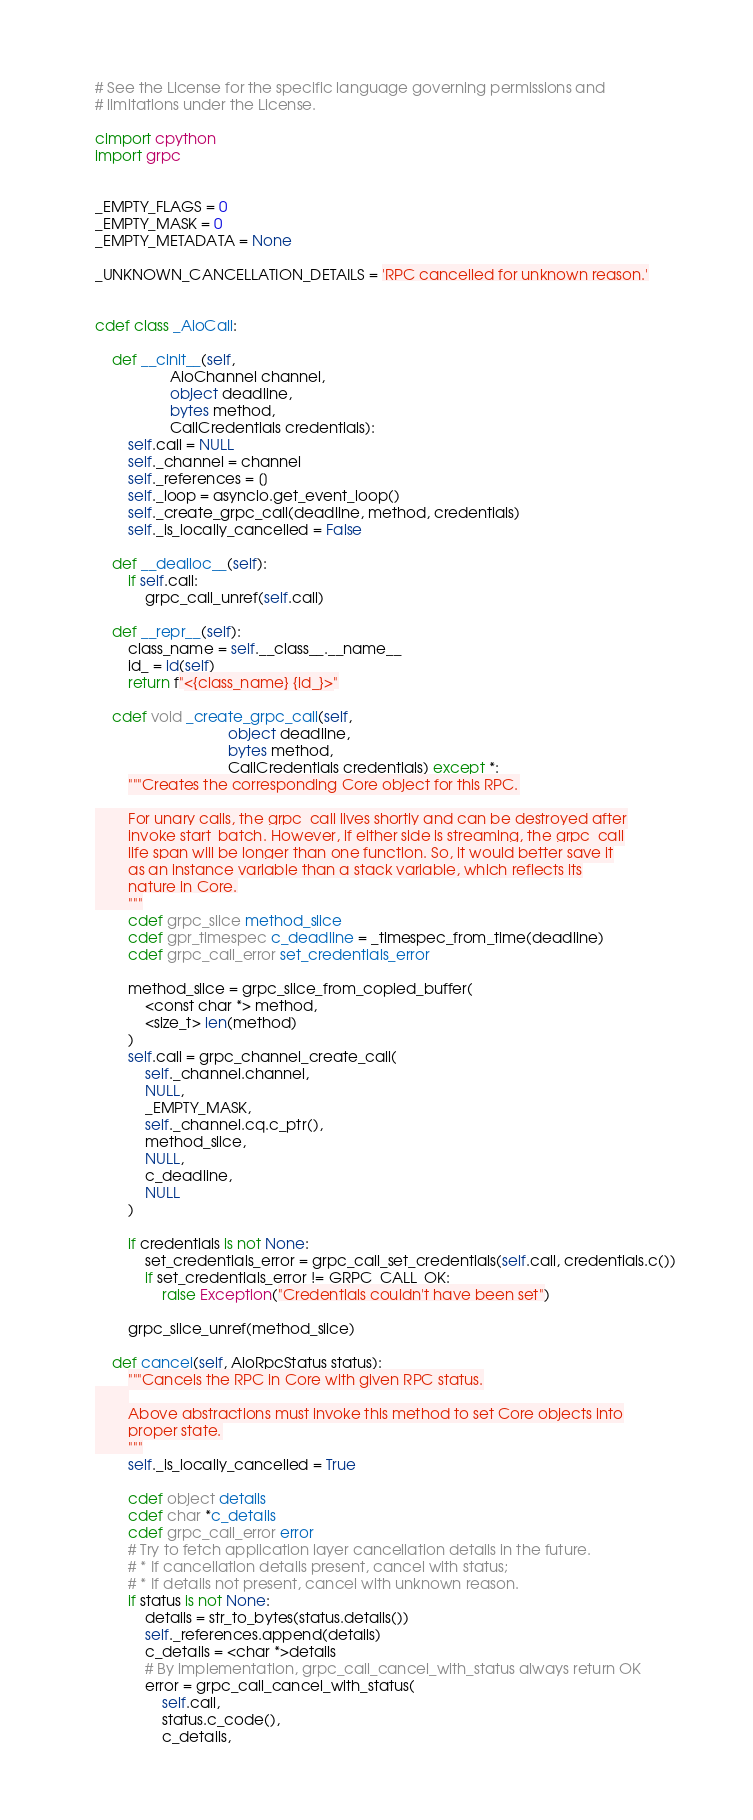<code> <loc_0><loc_0><loc_500><loc_500><_Cython_># See the License for the specific language governing permissions and
# limitations under the License.

cimport cpython
import grpc


_EMPTY_FLAGS = 0
_EMPTY_MASK = 0
_EMPTY_METADATA = None

_UNKNOWN_CANCELLATION_DETAILS = 'RPC cancelled for unknown reason.'


cdef class _AioCall:

    def __cinit__(self,
                  AioChannel channel,
                  object deadline,
                  bytes method,
                  CallCredentials credentials):
        self.call = NULL
        self._channel = channel
        self._references = []
        self._loop = asyncio.get_event_loop()
        self._create_grpc_call(deadline, method, credentials)
        self._is_locally_cancelled = False

    def __dealloc__(self):
        if self.call:
            grpc_call_unref(self.call)

    def __repr__(self):
        class_name = self.__class__.__name__
        id_ = id(self)
        return f"<{class_name} {id_}>"

    cdef void _create_grpc_call(self,
                                object deadline,
                                bytes method,
                                CallCredentials credentials) except *:
        """Creates the corresponding Core object for this RPC.

        For unary calls, the grpc_call lives shortly and can be destroyed after
        invoke start_batch. However, if either side is streaming, the grpc_call
        life span will be longer than one function. So, it would better save it
        as an instance variable than a stack variable, which reflects its
        nature in Core.
        """
        cdef grpc_slice method_slice
        cdef gpr_timespec c_deadline = _timespec_from_time(deadline)
        cdef grpc_call_error set_credentials_error

        method_slice = grpc_slice_from_copied_buffer(
            <const char *> method,
            <size_t> len(method)
        )
        self.call = grpc_channel_create_call(
            self._channel.channel,
            NULL,
            _EMPTY_MASK,
            self._channel.cq.c_ptr(),
            method_slice,
            NULL,
            c_deadline,
            NULL
        )

        if credentials is not None:
            set_credentials_error = grpc_call_set_credentials(self.call, credentials.c())
            if set_credentials_error != GRPC_CALL_OK:
                raise Exception("Credentials couldn't have been set")

        grpc_slice_unref(method_slice)

    def cancel(self, AioRpcStatus status):
        """Cancels the RPC in Core with given RPC status.
        
        Above abstractions must invoke this method to set Core objects into
        proper state.
        """
        self._is_locally_cancelled = True

        cdef object details
        cdef char *c_details
        cdef grpc_call_error error
        # Try to fetch application layer cancellation details in the future.
        # * If cancellation details present, cancel with status;
        # * If details not present, cancel with unknown reason.
        if status is not None:
            details = str_to_bytes(status.details())
            self._references.append(details)
            c_details = <char *>details
            # By implementation, grpc_call_cancel_with_status always return OK
            error = grpc_call_cancel_with_status(
                self.call,
                status.c_code(),
                c_details,</code> 